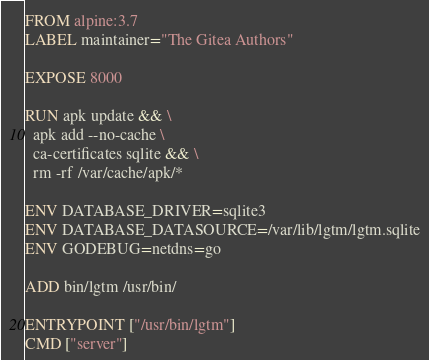Convert code to text. <code><loc_0><loc_0><loc_500><loc_500><_Dockerfile_>FROM alpine:3.7
LABEL maintainer="The Gitea Authors"

EXPOSE 8000

RUN apk update && \
  apk add --no-cache \
  ca-certificates sqlite && \
  rm -rf /var/cache/apk/*

ENV DATABASE_DRIVER=sqlite3
ENV DATABASE_DATASOURCE=/var/lib/lgtm/lgtm.sqlite
ENV GODEBUG=netdns=go

ADD bin/lgtm /usr/bin/

ENTRYPOINT ["/usr/bin/lgtm"]
CMD ["server"]
</code> 